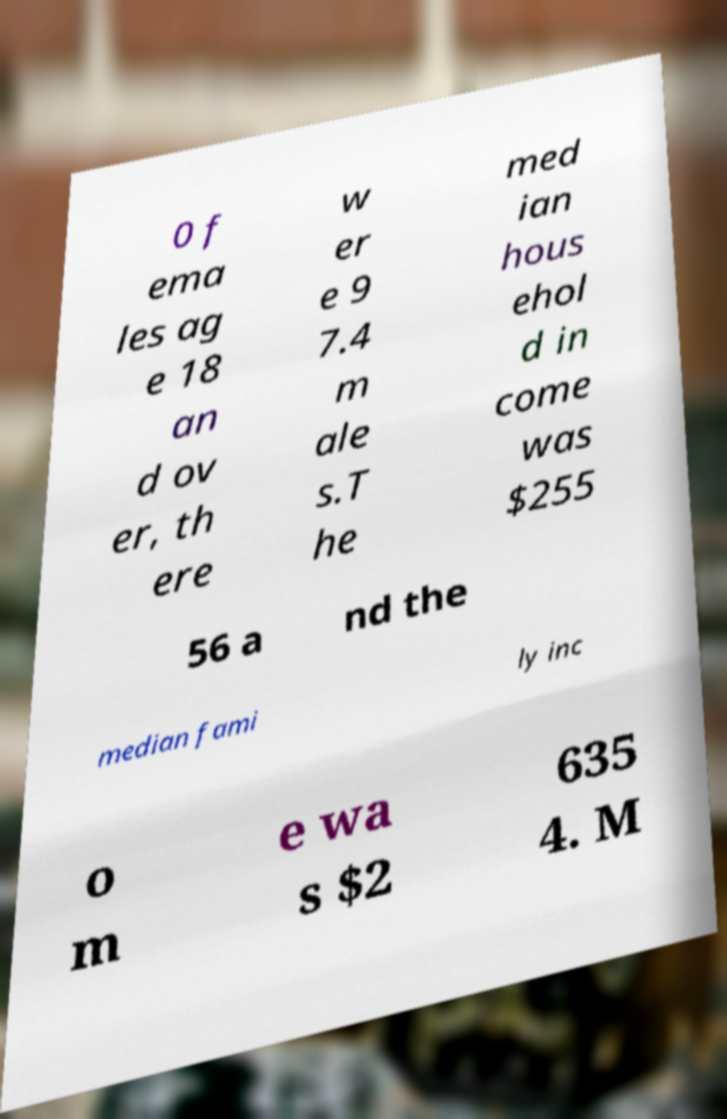Can you accurately transcribe the text from the provided image for me? 0 f ema les ag e 18 an d ov er, th ere w er e 9 7.4 m ale s.T he med ian hous ehol d in come was $255 56 a nd the median fami ly inc o m e wa s $2 635 4. M 